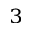<formula> <loc_0><loc_0><loc_500><loc_500>_ { 3 }</formula> 